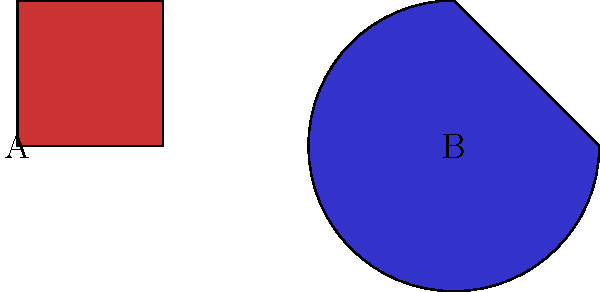Imagine you're creating a passionate, symmetrical artwork. Which rotation of shape B would create perfect symmetry when placed next to shape A? To solve this problem, we need to analyze the shapes and visualize their rotations:

1. Shape A is a square positioned in its default orientation.
2. Shape B is a 3/4 circle (270° arc) rotated 90° clockwise.
3. To create symmetry, we need to rotate shape B so that its flat edge aligns with the flat edge of shape A.
4. The flat edge of shape A is on the left side.
5. To match this, we need to rotate shape B so its flat edge is on the right side.
6. This can be achieved by rotating shape B 180° from its current position.
7. Since shape B is already rotated 90° clockwise, we need to rotate it an additional 90° clockwise.
8. Therefore, the total rotation from the original position would be 180° clockwise.

This rotation will create a passionate, symmetrical artwork with the two shapes complementing each other perfectly.
Answer: 180° clockwise 